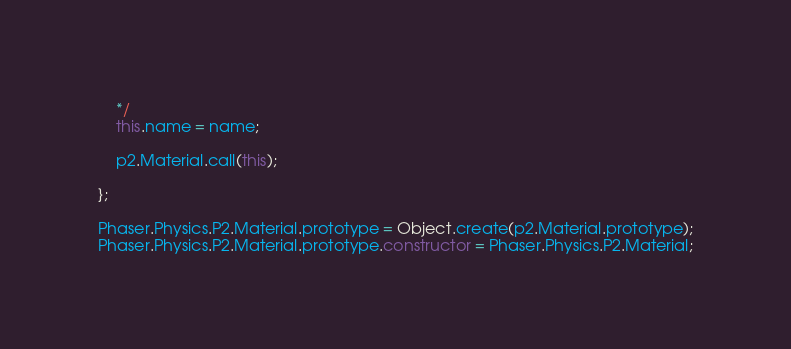<code> <loc_0><loc_0><loc_500><loc_500><_JavaScript_>    */
    this.name = name;

    p2.Material.call(this);

};

Phaser.Physics.P2.Material.prototype = Object.create(p2.Material.prototype);
Phaser.Physics.P2.Material.prototype.constructor = Phaser.Physics.P2.Material;
</code> 